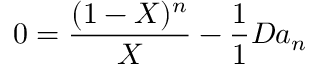<formula> <loc_0><loc_0><loc_500><loc_500>0 = { \frac { ( 1 - X ) ^ { n } } { X } } - { \frac { 1 } { 1 } { { D a _ { n } } } }</formula> 